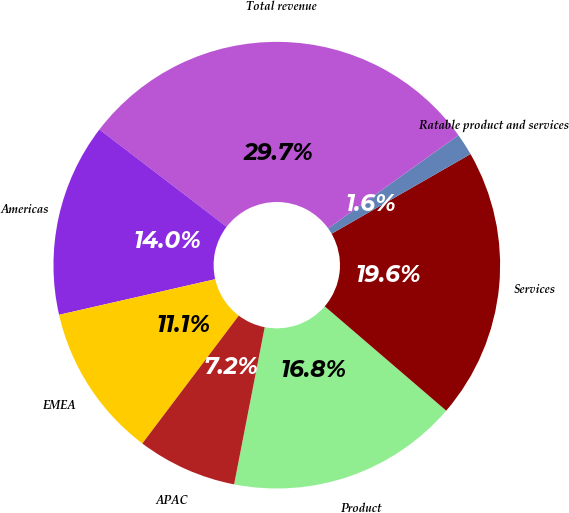<chart> <loc_0><loc_0><loc_500><loc_500><pie_chart><fcel>Product<fcel>Services<fcel>Ratable product and services<fcel>Total revenue<fcel>Americas<fcel>EMEA<fcel>APAC<nl><fcel>16.77%<fcel>19.58%<fcel>1.6%<fcel>29.72%<fcel>13.96%<fcel>11.15%<fcel>7.22%<nl></chart> 